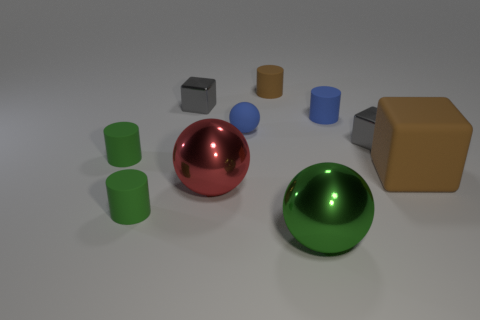Subtract all tiny brown cylinders. How many cylinders are left? 3 Subtract all gray cylinders. How many gray blocks are left? 2 Subtract all cylinders. How many objects are left? 6 Subtract 2 cubes. How many cubes are left? 1 Subtract all brown cubes. How many cubes are left? 2 Subtract all tiny blue cylinders. Subtract all red balls. How many objects are left? 8 Add 7 big green metal things. How many big green metal things are left? 8 Add 1 small brown rubber objects. How many small brown rubber objects exist? 2 Subtract 0 gray balls. How many objects are left? 10 Subtract all red cylinders. Subtract all red cubes. How many cylinders are left? 4 